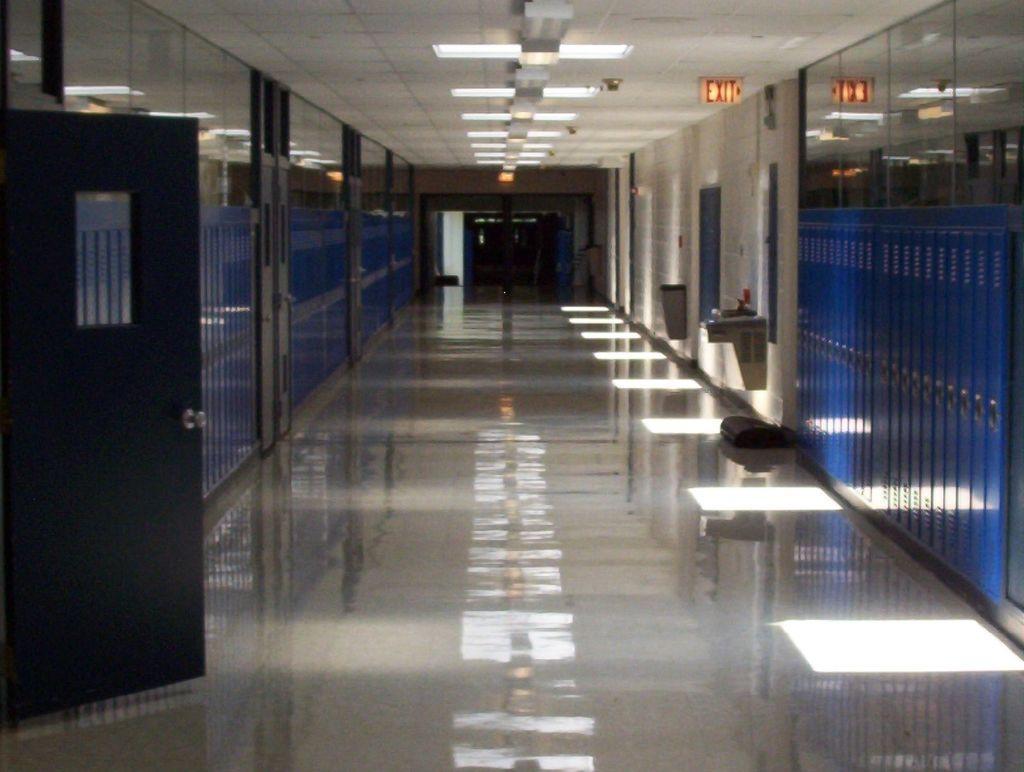In one or two sentences, can you explain what this image depicts? In this image we can see there is an inside view of the building. And there are glasses and door. And there is the stand attached to the wall and there are a few objects. And there is a black color object. At the top there is an exit board and ceiling with lights. 